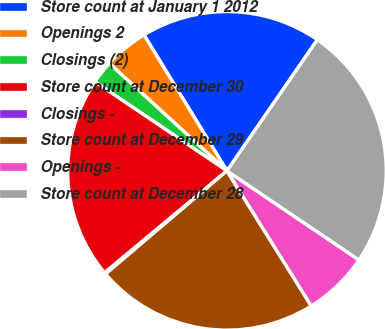<chart> <loc_0><loc_0><loc_500><loc_500><pie_chart><fcel>Store count at January 1 2012<fcel>Openings 2<fcel>Closings (2)<fcel>Store count at December 30<fcel>Closings -<fcel>Store count at December 29<fcel>Openings -<fcel>Store count at December 28<nl><fcel>18.33%<fcel>4.5%<fcel>2.33%<fcel>20.5%<fcel>0.16%<fcel>22.67%<fcel>6.67%<fcel>24.84%<nl></chart> 